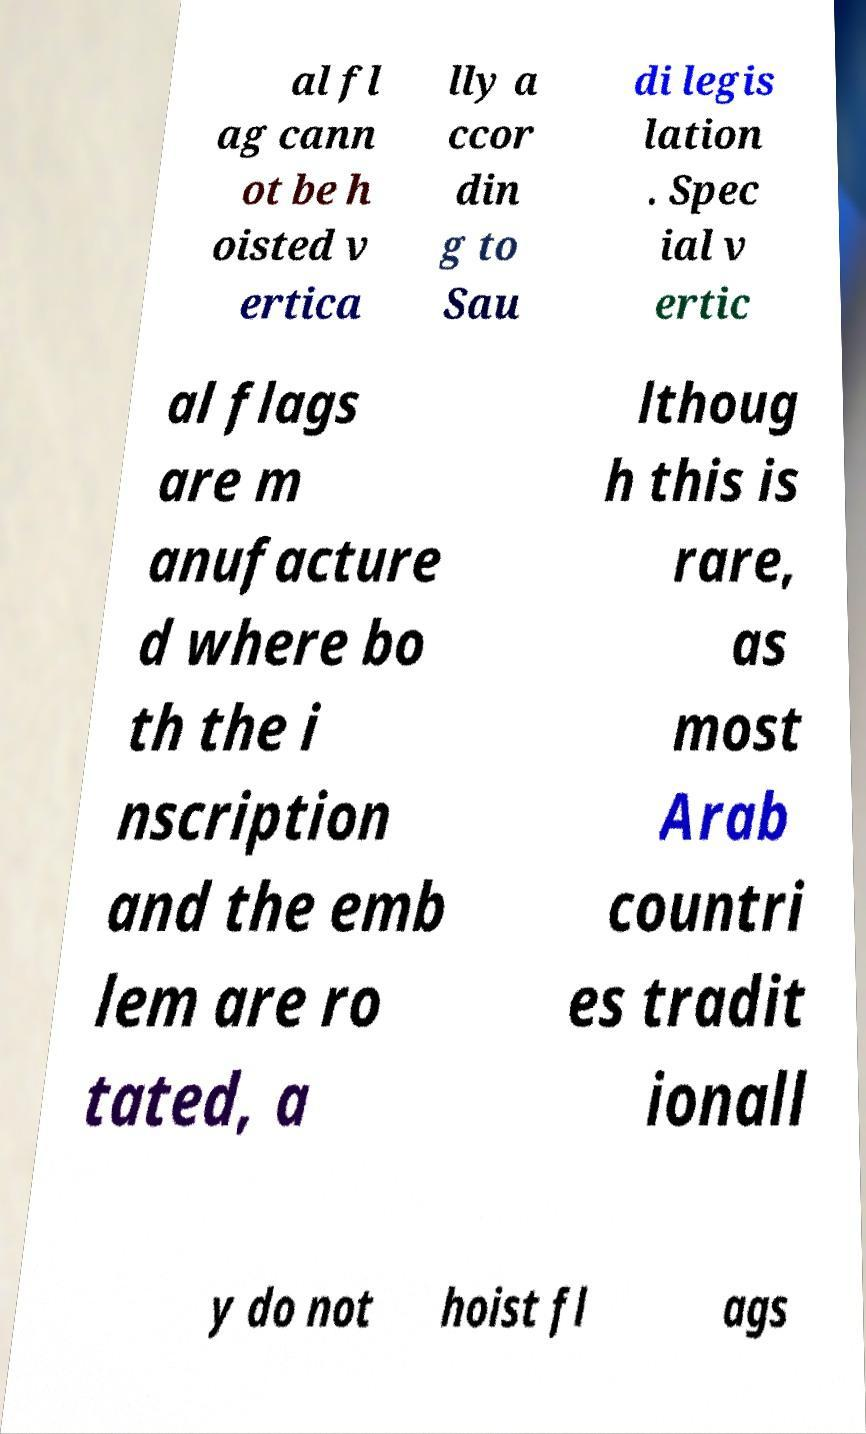Please read and relay the text visible in this image. What does it say? al fl ag cann ot be h oisted v ertica lly a ccor din g to Sau di legis lation . Spec ial v ertic al flags are m anufacture d where bo th the i nscription and the emb lem are ro tated, a lthoug h this is rare, as most Arab countri es tradit ionall y do not hoist fl ags 